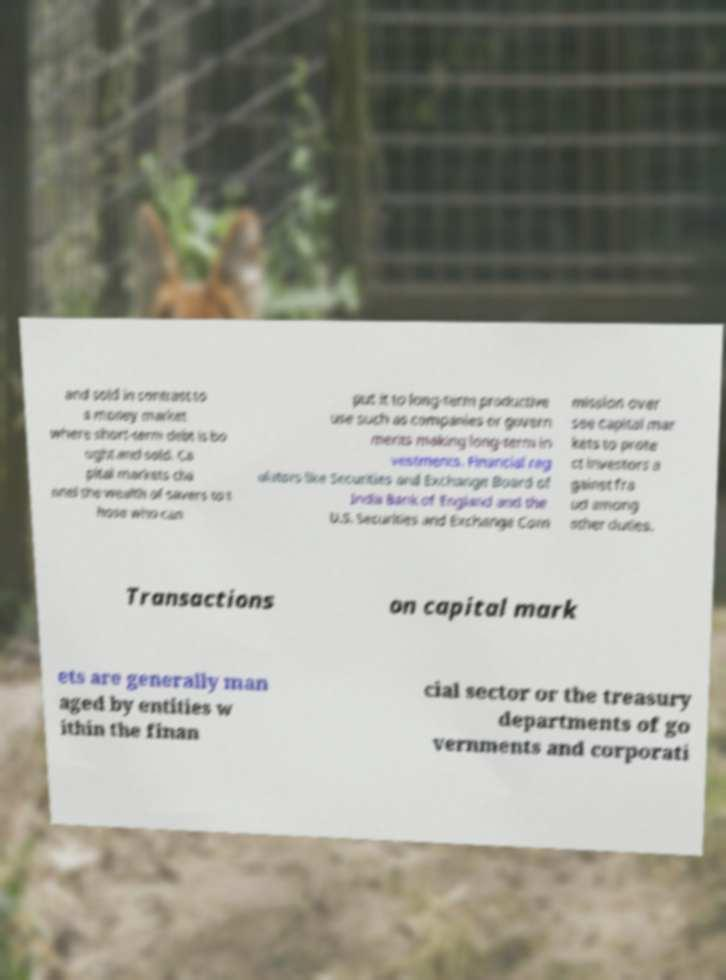Can you read and provide the text displayed in the image?This photo seems to have some interesting text. Can you extract and type it out for me? and sold in contrast to a money market where short-term debt is bo ught and sold. Ca pital markets cha nnel the wealth of savers to t hose who can put it to long-term productive use such as companies or govern ments making long-term in vestments. Financial reg ulators like Securities and Exchange Board of India Bank of England and the U.S. Securities and Exchange Com mission over see capital mar kets to prote ct investors a gainst fra ud among other duties. Transactions on capital mark ets are generally man aged by entities w ithin the finan cial sector or the treasury departments of go vernments and corporati 